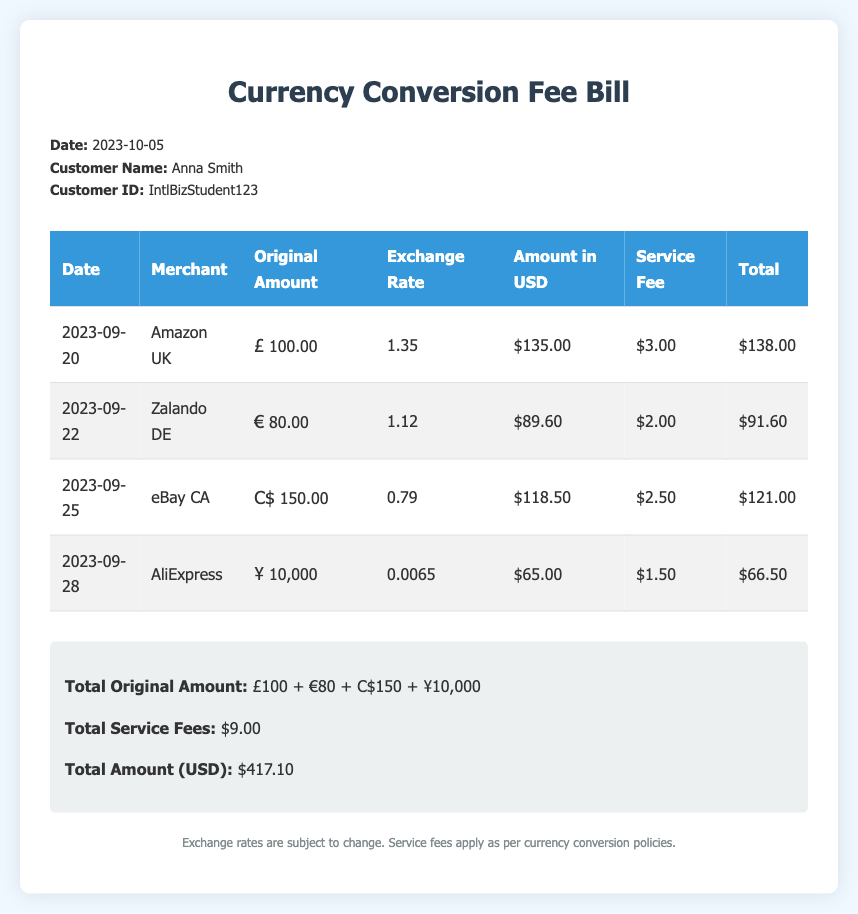What is the date of the bill? The date of the bill is mentioned in the header section of the document.
Answer: 2023-10-05 Who is the customer? The customer name is provided in the header information section.
Answer: Anna Smith What is the total service fees? The total service fees are calculated and summarized in the totals section.
Answer: $9.00 What is the original amount spent at Amazon UK? The original amount for the transaction at Amazon UK is listed in the transaction table.
Answer: £100.00 What was the exchange rate for the transaction at Zalando DE? The exchange rate for Zalando DE is given in the transaction details.
Answer: 1.12 What is the total amount in USD? The total amount in USD is summed in the totals section of the document.
Answer: $417.10 Which merchant had the highest original amount? The merchant with the highest original amount can be identified from the transaction table.
Answer: Amazon UK What is the service fee for the AliExpress transaction? The service fee for AliExpress is specified in the transaction table.
Answer: $1.50 What is the amount in USD for the eBay CA transaction? The amount in USD for the eBay CA transaction is provided in the transaction summary.
Answer: $118.50 